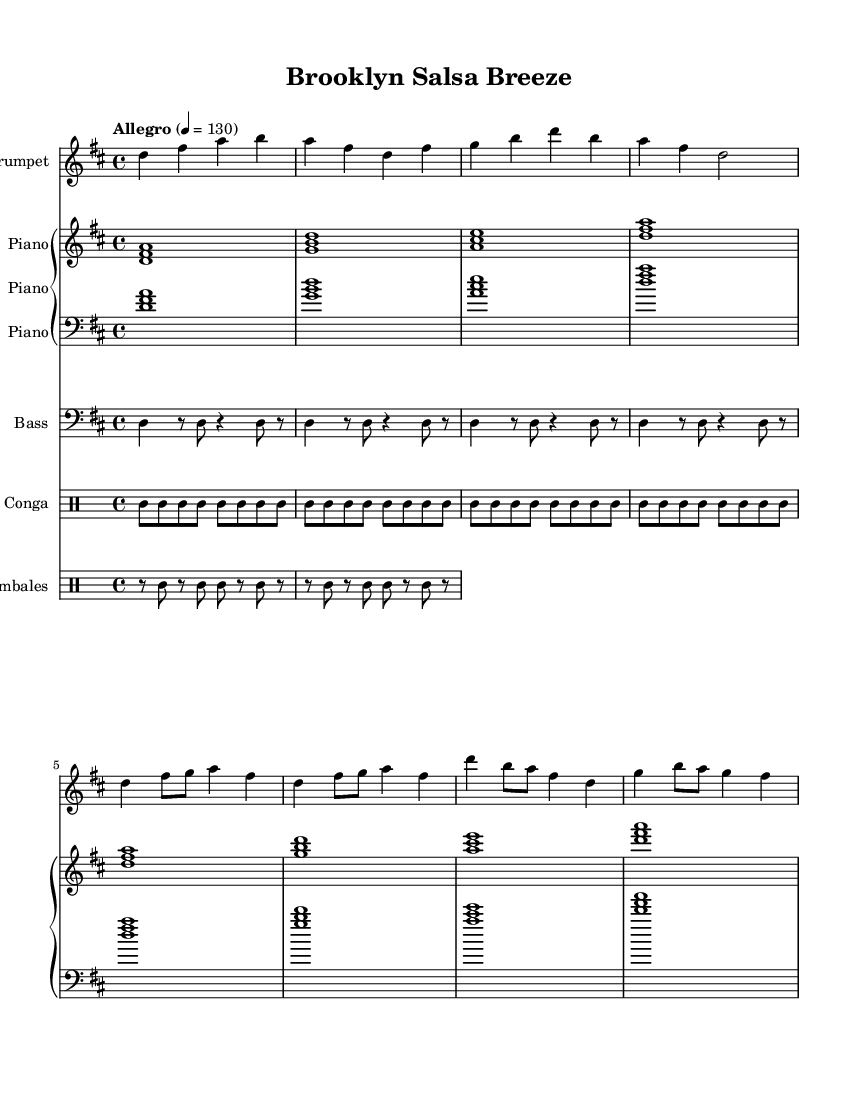What is the key signature of this music? The key signature is indicated by the sharps or flats present at the beginning of the staff. In this case, there are two sharps (F# and C#), indicating D major.
Answer: D major What is the time signature of this sheet music? The time signature is found at the beginning of the staff notation, represented as a fraction. Here, it is written as 4 over 4, which signifies four beats per measure.
Answer: 4/4 What is the tempo marking for this piece? The tempo marking is expressed at the start of the score, giving an indication of the speed. In this case, it is marked as "Allegro" with a metronome marking of 130 beats per minute.
Answer: Allegro, 130 Which instruments are featured in this sheet music? The instruments are indicated at the start of each staff with their respective names. The score includes trumpet, piano, bass, conga, and timbales.
Answer: Trumpet, Piano, Bass, Conga, Timbales How many measures are in the trumpet part provided? To determine this, you would count the number of groups of four beats, represented by the vertical barlines in the trumpet staff. The provided trumpet part contains a total of 8 measures.
Answer: 8 measures Which instrument plays the rhythm in the conga part? The conga part features a repeating rhythmic pattern that corresponds to the drum staff. The pattern consists of strokes and rests that characterize the conga sound, indicating it is specifically played on the conga drum.
Answer: Conga What is the primary genre influence evident in this sheet music? The style and instrumentation indicate a specific genre associated with rhythmic and melodic elements characteristic of Latin music, particularly with hints of salsa influences as suggested by the title.
Answer: Salsa 